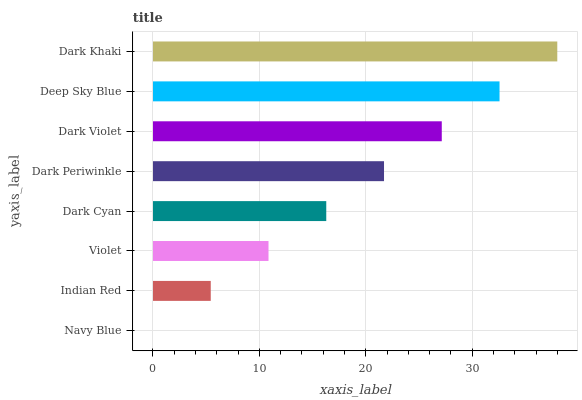Is Navy Blue the minimum?
Answer yes or no. Yes. Is Dark Khaki the maximum?
Answer yes or no. Yes. Is Indian Red the minimum?
Answer yes or no. No. Is Indian Red the maximum?
Answer yes or no. No. Is Indian Red greater than Navy Blue?
Answer yes or no. Yes. Is Navy Blue less than Indian Red?
Answer yes or no. Yes. Is Navy Blue greater than Indian Red?
Answer yes or no. No. Is Indian Red less than Navy Blue?
Answer yes or no. No. Is Dark Periwinkle the high median?
Answer yes or no. Yes. Is Dark Cyan the low median?
Answer yes or no. Yes. Is Dark Violet the high median?
Answer yes or no. No. Is Dark Periwinkle the low median?
Answer yes or no. No. 